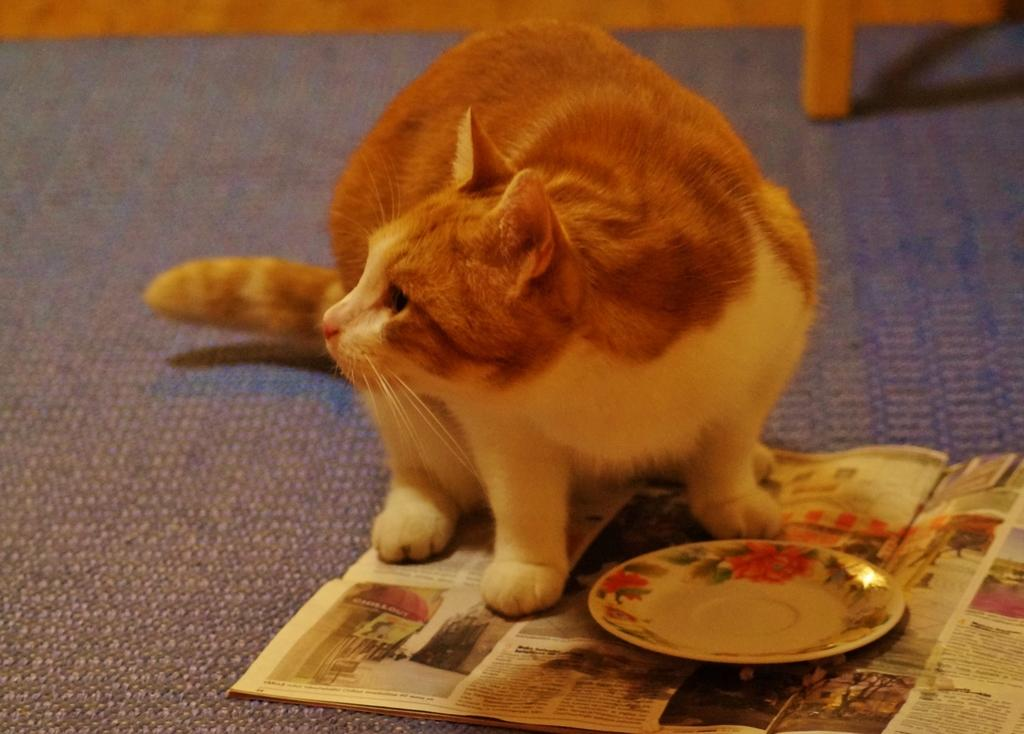What type of animal is present in the image? There is a cat in the image. What object is visible near the cat? There is a plate in the image. What can be seen in the background of the image? There is a newspaper in the image. What type of flooring is present in the image? There is a carpet in the image. What type of account does the kitten have with the bank in the image? There is no kitten present in the image, and therefore no account or bank-related information can be determined. 